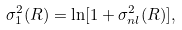<formula> <loc_0><loc_0><loc_500><loc_500>\sigma _ { 1 } ^ { 2 } ( R ) = \ln [ 1 + \sigma _ { n l } ^ { 2 } ( R ) ] ,</formula> 